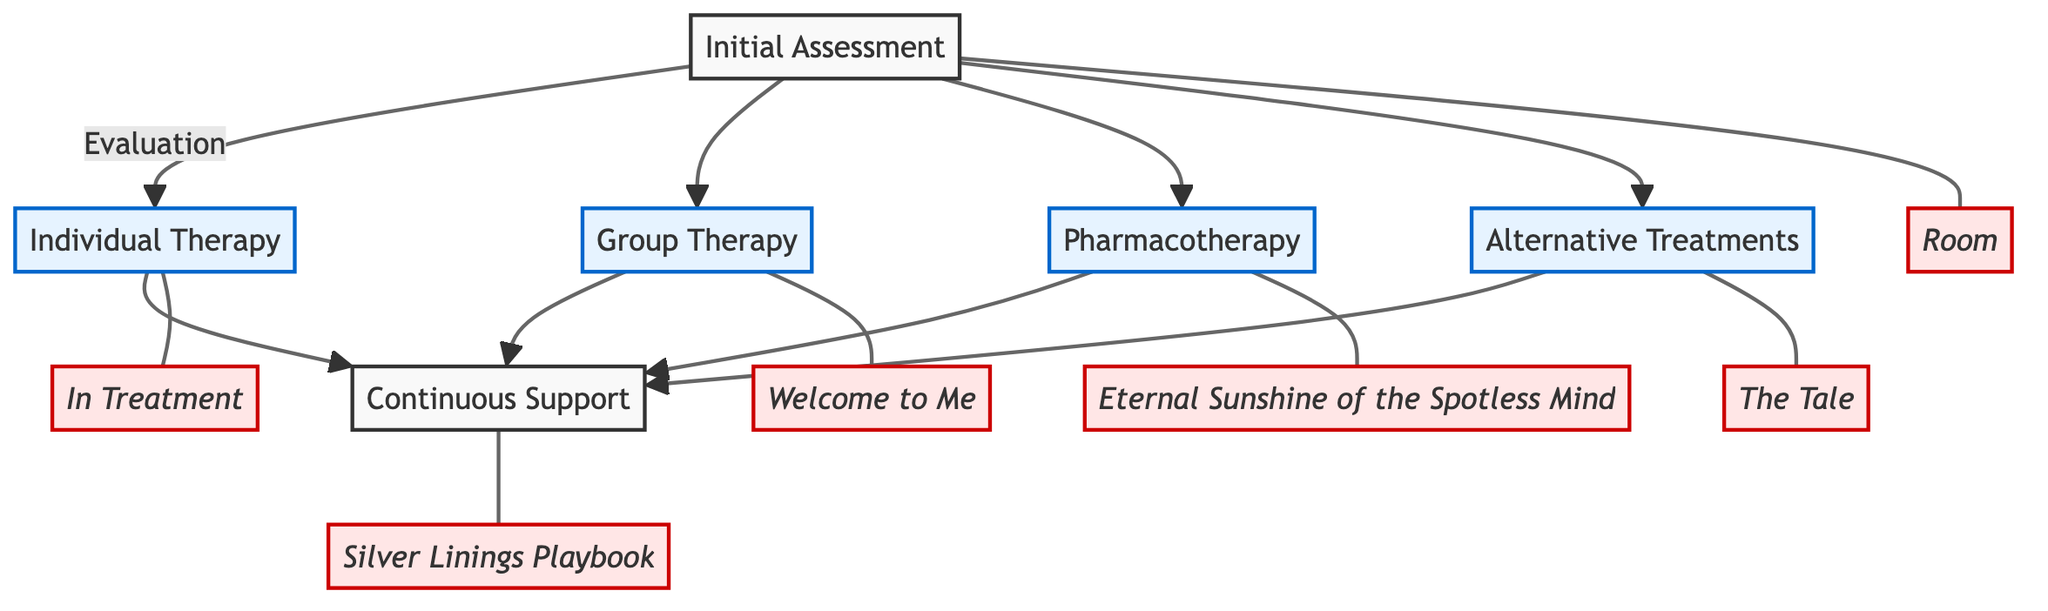What is the first step in the clinical pathway? The initial step in the diagram is "Initial Assessment," which is the starting node before proceeding to treatment options.
Answer: Initial Assessment How many therapy types are shown in this diagram? The diagram presents four treatment types branching from the "Initial Assessment" node: Individual Therapy, Group Therapy, Pharmacotherapy, and Alternative Treatments. Hence, there are four therapy types.
Answer: 4 What film features a character undergoing an "Individual Therapy" session? In the examples connected to "Individual Therapy," the film mentioned is "In Treatment," where the character Sophie has a therapy session.
Answer: In Treatment Which treatment types lead to "Continuous Support"? The treatment types that lead to "Continuous Support" are Individual Therapy, Group Therapy, Pharmacotherapy, and Alternative Treatments, indicating all types connect back to this support stage.
Answer: Individual Therapy, Group Therapy, Pharmacotherapy, Alternative Treatments What is the primary focus of "Group Therapy"? The description of "Group Therapy" mentions that it focuses on sharing traumatic experiences, developing coping strategies, and offering mutual support in a group setting.
Answer: Peer support Which character uses art to process trauma according to the diagram? The diagram shows "The Tale" as an example, where the character Jennifer uses writing as an alternative treatment to manage her trauma.
Answer: Jennifer Fox How many films are associated with the "Pharmacotherapy" treatment type? Only one film is highlighted in the diagram regarding "Pharmacotherapy," which is "Eternal Sunshine of the Spotless Mind," featuring a character who uses medication for anxiety.
Answer: 1 Which therapeutic method is categorized under "Alternative Treatments"? The diagram lists various non-traditional methods, with mindfulness and meditation being one of the treatments categorized under "Alternative Treatments."
Answer: Mindfulness and meditation What is the last step in the clinical pathway? The last step in the clinical pathway is "Continuous Support," which follows all treatment types after the initial assessment and therapies have been administered.
Answer: Continuous Support 